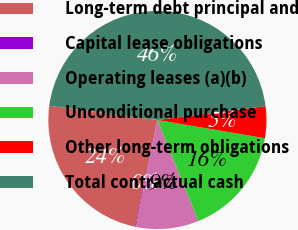Convert chart to OTSL. <chart><loc_0><loc_0><loc_500><loc_500><pie_chart><fcel>Long-term debt principal and<fcel>Capital lease obligations<fcel>Operating leases (a)(b)<fcel>Unconditional purchase<fcel>Other long-term obligations<fcel>Total contractual cash<nl><fcel>23.83%<fcel>0.11%<fcel>9.27%<fcel>16.2%<fcel>4.69%<fcel>45.9%<nl></chart> 